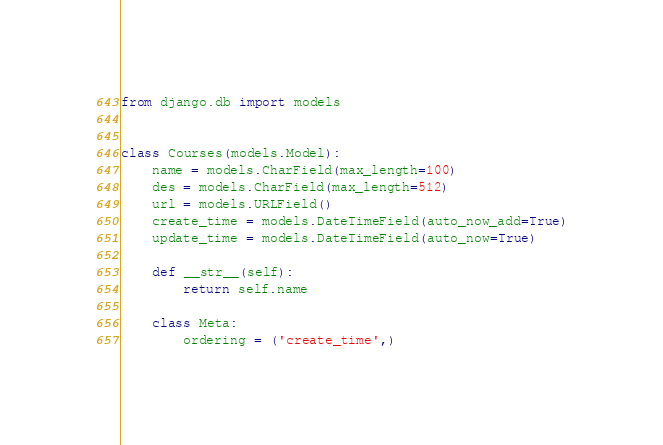<code> <loc_0><loc_0><loc_500><loc_500><_Python_>from django.db import models


class Courses(models.Model):
    name = models.CharField(max_length=100)
    des = models.CharField(max_length=512)
    url = models.URLField()
    create_time = models.DateTimeField(auto_now_add=True)
    update_time = models.DateTimeField(auto_now=True)

    def __str__(self):
        return self.name

    class Meta:
        ordering = ('create_time',)
</code> 